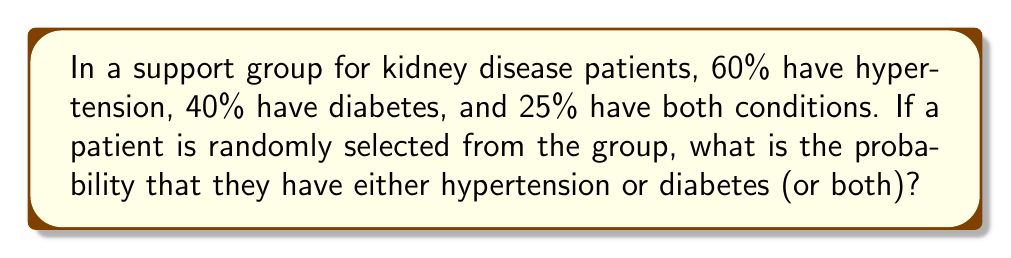Help me with this question. Let's approach this step-by-step using the addition rule of probability:

1) Let H be the event of having hypertension, and D be the event of having diabetes.

2) We're given:
   P(H) = 0.60
   P(D) = 0.40
   P(H ∩ D) = 0.25

3) We want to find P(H ∪ D), which is the probability of having either hypertension or diabetes (or both).

4) The addition rule of probability states:

   $$P(H \cup D) = P(H) + P(D) - P(H \cap D)$$

5) Substituting the given values:

   $$P(H \cup D) = 0.60 + 0.40 - 0.25$$

6) Calculating:

   $$P(H \cup D) = 1.00 - 0.25 = 0.75$$

Therefore, the probability that a randomly selected patient has either hypertension or diabetes (or both) is 0.75 or 75%.
Answer: 0.75 